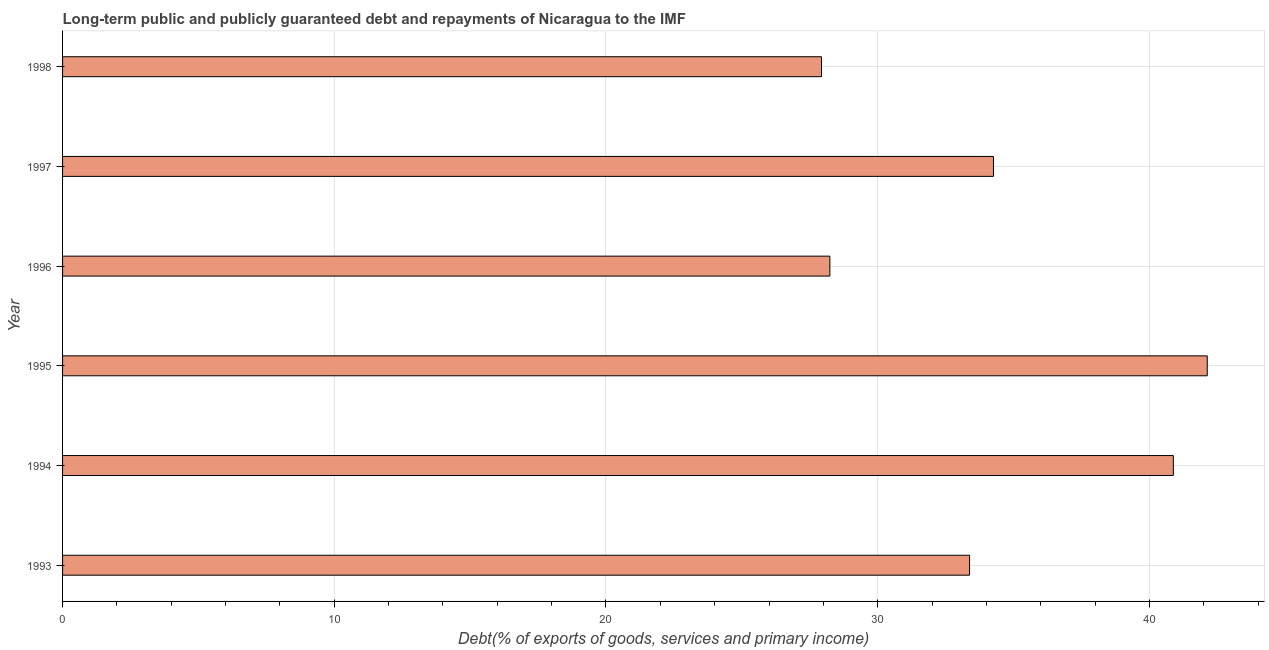What is the title of the graph?
Make the answer very short. Long-term public and publicly guaranteed debt and repayments of Nicaragua to the IMF. What is the label or title of the X-axis?
Provide a short and direct response. Debt(% of exports of goods, services and primary income). What is the debt service in 1994?
Ensure brevity in your answer.  40.88. Across all years, what is the maximum debt service?
Your response must be concise. 42.13. Across all years, what is the minimum debt service?
Give a very brief answer. 27.93. In which year was the debt service minimum?
Offer a terse response. 1998. What is the sum of the debt service?
Give a very brief answer. 206.83. What is the difference between the debt service in 1993 and 1998?
Your answer should be very brief. 5.45. What is the average debt service per year?
Your answer should be compact. 34.47. What is the median debt service?
Give a very brief answer. 33.82. What is the ratio of the debt service in 1994 to that in 1998?
Offer a very short reply. 1.46. Is the debt service in 1994 less than that in 1996?
Your response must be concise. No. Is the difference between the debt service in 1994 and 1996 greater than the difference between any two years?
Your response must be concise. No. What is the difference between the highest and the second highest debt service?
Offer a very short reply. 1.25. Are all the bars in the graph horizontal?
Offer a very short reply. Yes. How many years are there in the graph?
Provide a short and direct response. 6. Are the values on the major ticks of X-axis written in scientific E-notation?
Your response must be concise. No. What is the Debt(% of exports of goods, services and primary income) of 1993?
Keep it short and to the point. 33.38. What is the Debt(% of exports of goods, services and primary income) in 1994?
Offer a very short reply. 40.88. What is the Debt(% of exports of goods, services and primary income) of 1995?
Give a very brief answer. 42.13. What is the Debt(% of exports of goods, services and primary income) of 1996?
Ensure brevity in your answer.  28.24. What is the Debt(% of exports of goods, services and primary income) in 1997?
Your answer should be very brief. 34.26. What is the Debt(% of exports of goods, services and primary income) of 1998?
Offer a terse response. 27.93. What is the difference between the Debt(% of exports of goods, services and primary income) in 1993 and 1994?
Make the answer very short. -7.5. What is the difference between the Debt(% of exports of goods, services and primary income) in 1993 and 1995?
Give a very brief answer. -8.75. What is the difference between the Debt(% of exports of goods, services and primary income) in 1993 and 1996?
Offer a very short reply. 5.14. What is the difference between the Debt(% of exports of goods, services and primary income) in 1993 and 1997?
Ensure brevity in your answer.  -0.88. What is the difference between the Debt(% of exports of goods, services and primary income) in 1993 and 1998?
Keep it short and to the point. 5.45. What is the difference between the Debt(% of exports of goods, services and primary income) in 1994 and 1995?
Make the answer very short. -1.25. What is the difference between the Debt(% of exports of goods, services and primary income) in 1994 and 1996?
Offer a terse response. 12.64. What is the difference between the Debt(% of exports of goods, services and primary income) in 1994 and 1997?
Your answer should be very brief. 6.62. What is the difference between the Debt(% of exports of goods, services and primary income) in 1994 and 1998?
Your answer should be compact. 12.95. What is the difference between the Debt(% of exports of goods, services and primary income) in 1995 and 1996?
Provide a succinct answer. 13.89. What is the difference between the Debt(% of exports of goods, services and primary income) in 1995 and 1997?
Offer a terse response. 7.87. What is the difference between the Debt(% of exports of goods, services and primary income) in 1995 and 1998?
Keep it short and to the point. 14.2. What is the difference between the Debt(% of exports of goods, services and primary income) in 1996 and 1997?
Ensure brevity in your answer.  -6.02. What is the difference between the Debt(% of exports of goods, services and primary income) in 1996 and 1998?
Offer a very short reply. 0.31. What is the difference between the Debt(% of exports of goods, services and primary income) in 1997 and 1998?
Your answer should be compact. 6.33. What is the ratio of the Debt(% of exports of goods, services and primary income) in 1993 to that in 1994?
Your answer should be compact. 0.82. What is the ratio of the Debt(% of exports of goods, services and primary income) in 1993 to that in 1995?
Offer a terse response. 0.79. What is the ratio of the Debt(% of exports of goods, services and primary income) in 1993 to that in 1996?
Make the answer very short. 1.18. What is the ratio of the Debt(% of exports of goods, services and primary income) in 1993 to that in 1998?
Your response must be concise. 1.2. What is the ratio of the Debt(% of exports of goods, services and primary income) in 1994 to that in 1996?
Provide a succinct answer. 1.45. What is the ratio of the Debt(% of exports of goods, services and primary income) in 1994 to that in 1997?
Provide a short and direct response. 1.19. What is the ratio of the Debt(% of exports of goods, services and primary income) in 1994 to that in 1998?
Your answer should be compact. 1.46. What is the ratio of the Debt(% of exports of goods, services and primary income) in 1995 to that in 1996?
Provide a short and direct response. 1.49. What is the ratio of the Debt(% of exports of goods, services and primary income) in 1995 to that in 1997?
Offer a terse response. 1.23. What is the ratio of the Debt(% of exports of goods, services and primary income) in 1995 to that in 1998?
Give a very brief answer. 1.51. What is the ratio of the Debt(% of exports of goods, services and primary income) in 1996 to that in 1997?
Offer a terse response. 0.82. What is the ratio of the Debt(% of exports of goods, services and primary income) in 1996 to that in 1998?
Your response must be concise. 1.01. What is the ratio of the Debt(% of exports of goods, services and primary income) in 1997 to that in 1998?
Provide a succinct answer. 1.23. 